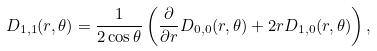Convert formula to latex. <formula><loc_0><loc_0><loc_500><loc_500>D _ { 1 , 1 } ( r , \theta ) = \frac { 1 } { 2 \cos \theta } \left ( \frac { \partial } { \partial r } D _ { 0 , 0 } ( r , \theta ) + 2 r D _ { 1 , 0 } ( r , \theta ) \right ) ,</formula> 